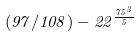Convert formula to latex. <formula><loc_0><loc_0><loc_500><loc_500>( 9 7 / 1 0 8 ) - 2 2 ^ { \frac { 7 5 ^ { 3 } } { 5 } }</formula> 